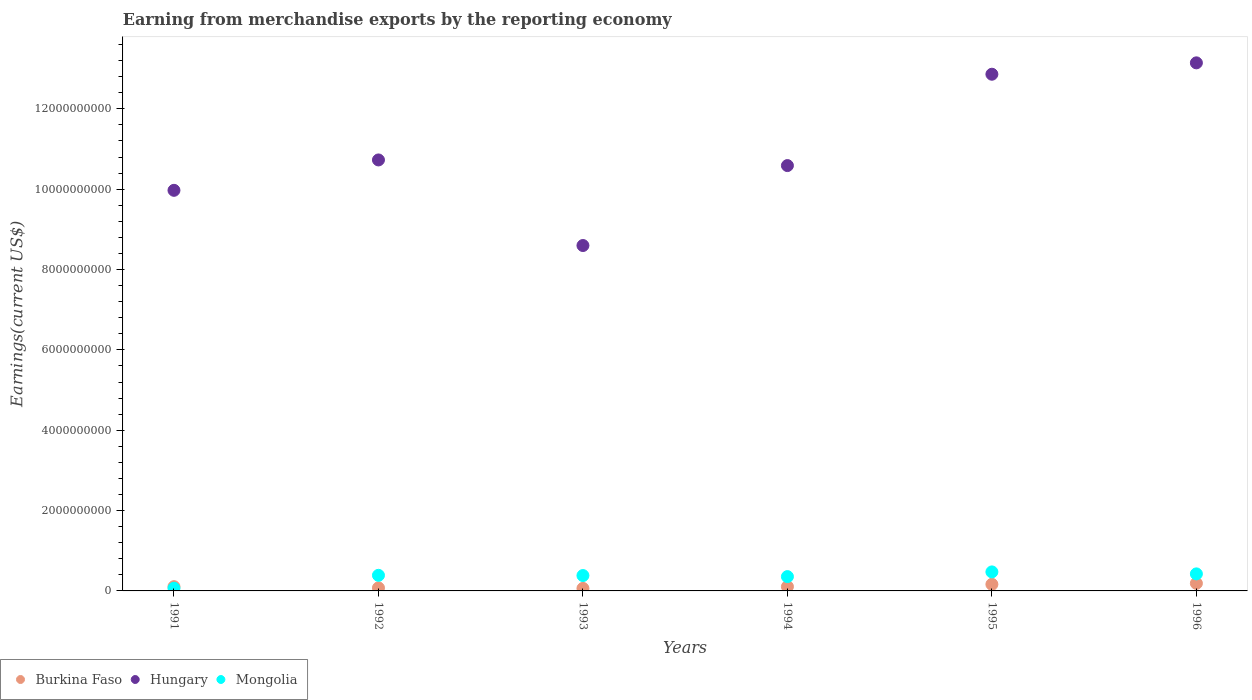Is the number of dotlines equal to the number of legend labels?
Provide a short and direct response. Yes. What is the amount earned from merchandise exports in Hungary in 1994?
Ensure brevity in your answer.  1.06e+1. Across all years, what is the maximum amount earned from merchandise exports in Mongolia?
Give a very brief answer. 4.73e+08. Across all years, what is the minimum amount earned from merchandise exports in Mongolia?
Give a very brief answer. 6.74e+07. In which year was the amount earned from merchandise exports in Burkina Faso maximum?
Your response must be concise. 1996. In which year was the amount earned from merchandise exports in Mongolia minimum?
Provide a succinct answer. 1991. What is the total amount earned from merchandise exports in Hungary in the graph?
Ensure brevity in your answer.  6.59e+1. What is the difference between the amount earned from merchandise exports in Hungary in 1992 and that in 1994?
Make the answer very short. 1.40e+08. What is the difference between the amount earned from merchandise exports in Hungary in 1994 and the amount earned from merchandise exports in Burkina Faso in 1992?
Provide a short and direct response. 1.05e+1. What is the average amount earned from merchandise exports in Mongolia per year?
Offer a terse response. 3.49e+08. In the year 1992, what is the difference between the amount earned from merchandise exports in Burkina Faso and amount earned from merchandise exports in Hungary?
Provide a short and direct response. -1.07e+1. What is the ratio of the amount earned from merchandise exports in Hungary in 1991 to that in 1993?
Ensure brevity in your answer.  1.16. What is the difference between the highest and the second highest amount earned from merchandise exports in Mongolia?
Keep it short and to the point. 4.90e+07. What is the difference between the highest and the lowest amount earned from merchandise exports in Mongolia?
Provide a succinct answer. 4.06e+08. In how many years, is the amount earned from merchandise exports in Hungary greater than the average amount earned from merchandise exports in Hungary taken over all years?
Provide a short and direct response. 2. Is the sum of the amount earned from merchandise exports in Burkina Faso in 1991 and 1996 greater than the maximum amount earned from merchandise exports in Mongolia across all years?
Offer a terse response. No. Is the amount earned from merchandise exports in Hungary strictly greater than the amount earned from merchandise exports in Burkina Faso over the years?
Offer a very short reply. Yes. What is the difference between two consecutive major ticks on the Y-axis?
Provide a succinct answer. 2.00e+09. Does the graph contain any zero values?
Provide a short and direct response. No. Does the graph contain grids?
Keep it short and to the point. No. How are the legend labels stacked?
Provide a succinct answer. Horizontal. What is the title of the graph?
Provide a short and direct response. Earning from merchandise exports by the reporting economy. What is the label or title of the X-axis?
Your answer should be very brief. Years. What is the label or title of the Y-axis?
Your answer should be very brief. Earnings(current US$). What is the Earnings(current US$) in Burkina Faso in 1991?
Your answer should be very brief. 1.06e+08. What is the Earnings(current US$) in Hungary in 1991?
Make the answer very short. 9.97e+09. What is the Earnings(current US$) of Mongolia in 1991?
Ensure brevity in your answer.  6.74e+07. What is the Earnings(current US$) in Burkina Faso in 1992?
Provide a succinct answer. 7.57e+07. What is the Earnings(current US$) in Hungary in 1992?
Offer a terse response. 1.07e+1. What is the Earnings(current US$) in Mongolia in 1992?
Provide a succinct answer. 3.88e+08. What is the Earnings(current US$) in Burkina Faso in 1993?
Provide a short and direct response. 6.25e+07. What is the Earnings(current US$) in Hungary in 1993?
Ensure brevity in your answer.  8.60e+09. What is the Earnings(current US$) in Mongolia in 1993?
Give a very brief answer. 3.83e+08. What is the Earnings(current US$) in Burkina Faso in 1994?
Keep it short and to the point. 1.07e+08. What is the Earnings(current US$) of Hungary in 1994?
Offer a terse response. 1.06e+1. What is the Earnings(current US$) of Mongolia in 1994?
Offer a terse response. 3.56e+08. What is the Earnings(current US$) in Burkina Faso in 1995?
Ensure brevity in your answer.  1.64e+08. What is the Earnings(current US$) of Hungary in 1995?
Make the answer very short. 1.29e+1. What is the Earnings(current US$) of Mongolia in 1995?
Your answer should be very brief. 4.73e+08. What is the Earnings(current US$) of Burkina Faso in 1996?
Provide a short and direct response. 1.89e+08. What is the Earnings(current US$) of Hungary in 1996?
Provide a succinct answer. 1.31e+1. What is the Earnings(current US$) of Mongolia in 1996?
Offer a terse response. 4.24e+08. Across all years, what is the maximum Earnings(current US$) in Burkina Faso?
Your answer should be very brief. 1.89e+08. Across all years, what is the maximum Earnings(current US$) in Hungary?
Keep it short and to the point. 1.31e+1. Across all years, what is the maximum Earnings(current US$) of Mongolia?
Your answer should be very brief. 4.73e+08. Across all years, what is the minimum Earnings(current US$) in Burkina Faso?
Your answer should be very brief. 6.25e+07. Across all years, what is the minimum Earnings(current US$) of Hungary?
Make the answer very short. 8.60e+09. Across all years, what is the minimum Earnings(current US$) in Mongolia?
Your answer should be compact. 6.74e+07. What is the total Earnings(current US$) of Burkina Faso in the graph?
Ensure brevity in your answer.  7.04e+08. What is the total Earnings(current US$) in Hungary in the graph?
Keep it short and to the point. 6.59e+1. What is the total Earnings(current US$) of Mongolia in the graph?
Offer a terse response. 2.09e+09. What is the difference between the Earnings(current US$) in Burkina Faso in 1991 and that in 1992?
Provide a short and direct response. 3.03e+07. What is the difference between the Earnings(current US$) in Hungary in 1991 and that in 1992?
Give a very brief answer. -7.56e+08. What is the difference between the Earnings(current US$) of Mongolia in 1991 and that in 1992?
Give a very brief answer. -3.21e+08. What is the difference between the Earnings(current US$) in Burkina Faso in 1991 and that in 1993?
Provide a short and direct response. 4.34e+07. What is the difference between the Earnings(current US$) of Hungary in 1991 and that in 1993?
Your answer should be very brief. 1.37e+09. What is the difference between the Earnings(current US$) in Mongolia in 1991 and that in 1993?
Offer a very short reply. -3.15e+08. What is the difference between the Earnings(current US$) in Burkina Faso in 1991 and that in 1994?
Give a very brief answer. -7.06e+05. What is the difference between the Earnings(current US$) of Hungary in 1991 and that in 1994?
Provide a short and direct response. -6.16e+08. What is the difference between the Earnings(current US$) in Mongolia in 1991 and that in 1994?
Your answer should be compact. -2.89e+08. What is the difference between the Earnings(current US$) of Burkina Faso in 1991 and that in 1995?
Keep it short and to the point. -5.84e+07. What is the difference between the Earnings(current US$) in Hungary in 1991 and that in 1995?
Ensure brevity in your answer.  -2.89e+09. What is the difference between the Earnings(current US$) of Mongolia in 1991 and that in 1995?
Make the answer very short. -4.06e+08. What is the difference between the Earnings(current US$) of Burkina Faso in 1991 and that in 1996?
Your answer should be compact. -8.27e+07. What is the difference between the Earnings(current US$) of Hungary in 1991 and that in 1996?
Your response must be concise. -3.17e+09. What is the difference between the Earnings(current US$) in Mongolia in 1991 and that in 1996?
Offer a very short reply. -3.57e+08. What is the difference between the Earnings(current US$) in Burkina Faso in 1992 and that in 1993?
Your response must be concise. 1.32e+07. What is the difference between the Earnings(current US$) in Hungary in 1992 and that in 1993?
Offer a very short reply. 2.13e+09. What is the difference between the Earnings(current US$) in Mongolia in 1992 and that in 1993?
Offer a terse response. 5.74e+06. What is the difference between the Earnings(current US$) in Burkina Faso in 1992 and that in 1994?
Ensure brevity in your answer.  -3.10e+07. What is the difference between the Earnings(current US$) of Hungary in 1992 and that in 1994?
Give a very brief answer. 1.40e+08. What is the difference between the Earnings(current US$) of Mongolia in 1992 and that in 1994?
Your response must be concise. 3.23e+07. What is the difference between the Earnings(current US$) of Burkina Faso in 1992 and that in 1995?
Give a very brief answer. -8.86e+07. What is the difference between the Earnings(current US$) of Hungary in 1992 and that in 1995?
Ensure brevity in your answer.  -2.13e+09. What is the difference between the Earnings(current US$) in Mongolia in 1992 and that in 1995?
Give a very brief answer. -8.49e+07. What is the difference between the Earnings(current US$) in Burkina Faso in 1992 and that in 1996?
Keep it short and to the point. -1.13e+08. What is the difference between the Earnings(current US$) in Hungary in 1992 and that in 1996?
Your answer should be compact. -2.42e+09. What is the difference between the Earnings(current US$) in Mongolia in 1992 and that in 1996?
Make the answer very short. -3.59e+07. What is the difference between the Earnings(current US$) in Burkina Faso in 1993 and that in 1994?
Provide a short and direct response. -4.41e+07. What is the difference between the Earnings(current US$) of Hungary in 1993 and that in 1994?
Provide a succinct answer. -1.99e+09. What is the difference between the Earnings(current US$) of Mongolia in 1993 and that in 1994?
Ensure brevity in your answer.  2.66e+07. What is the difference between the Earnings(current US$) in Burkina Faso in 1993 and that in 1995?
Provide a short and direct response. -1.02e+08. What is the difference between the Earnings(current US$) of Hungary in 1993 and that in 1995?
Offer a terse response. -4.26e+09. What is the difference between the Earnings(current US$) in Mongolia in 1993 and that in 1995?
Offer a terse response. -9.06e+07. What is the difference between the Earnings(current US$) in Burkina Faso in 1993 and that in 1996?
Give a very brief answer. -1.26e+08. What is the difference between the Earnings(current US$) of Hungary in 1993 and that in 1996?
Keep it short and to the point. -4.55e+09. What is the difference between the Earnings(current US$) in Mongolia in 1993 and that in 1996?
Give a very brief answer. -4.16e+07. What is the difference between the Earnings(current US$) of Burkina Faso in 1994 and that in 1995?
Your answer should be compact. -5.76e+07. What is the difference between the Earnings(current US$) in Hungary in 1994 and that in 1995?
Give a very brief answer. -2.27e+09. What is the difference between the Earnings(current US$) in Mongolia in 1994 and that in 1995?
Your answer should be compact. -1.17e+08. What is the difference between the Earnings(current US$) in Burkina Faso in 1994 and that in 1996?
Give a very brief answer. -8.20e+07. What is the difference between the Earnings(current US$) of Hungary in 1994 and that in 1996?
Provide a succinct answer. -2.56e+09. What is the difference between the Earnings(current US$) of Mongolia in 1994 and that in 1996?
Ensure brevity in your answer.  -6.82e+07. What is the difference between the Earnings(current US$) in Burkina Faso in 1995 and that in 1996?
Provide a short and direct response. -2.44e+07. What is the difference between the Earnings(current US$) of Hungary in 1995 and that in 1996?
Give a very brief answer. -2.83e+08. What is the difference between the Earnings(current US$) in Mongolia in 1995 and that in 1996?
Your answer should be compact. 4.90e+07. What is the difference between the Earnings(current US$) in Burkina Faso in 1991 and the Earnings(current US$) in Hungary in 1992?
Keep it short and to the point. -1.06e+1. What is the difference between the Earnings(current US$) of Burkina Faso in 1991 and the Earnings(current US$) of Mongolia in 1992?
Offer a very short reply. -2.82e+08. What is the difference between the Earnings(current US$) in Hungary in 1991 and the Earnings(current US$) in Mongolia in 1992?
Your answer should be compact. 9.58e+09. What is the difference between the Earnings(current US$) in Burkina Faso in 1991 and the Earnings(current US$) in Hungary in 1993?
Offer a terse response. -8.49e+09. What is the difference between the Earnings(current US$) of Burkina Faso in 1991 and the Earnings(current US$) of Mongolia in 1993?
Keep it short and to the point. -2.77e+08. What is the difference between the Earnings(current US$) of Hungary in 1991 and the Earnings(current US$) of Mongolia in 1993?
Your response must be concise. 9.59e+09. What is the difference between the Earnings(current US$) in Burkina Faso in 1991 and the Earnings(current US$) in Hungary in 1994?
Your response must be concise. -1.05e+1. What is the difference between the Earnings(current US$) in Burkina Faso in 1991 and the Earnings(current US$) in Mongolia in 1994?
Keep it short and to the point. -2.50e+08. What is the difference between the Earnings(current US$) in Hungary in 1991 and the Earnings(current US$) in Mongolia in 1994?
Provide a short and direct response. 9.62e+09. What is the difference between the Earnings(current US$) in Burkina Faso in 1991 and the Earnings(current US$) in Hungary in 1995?
Make the answer very short. -1.28e+1. What is the difference between the Earnings(current US$) of Burkina Faso in 1991 and the Earnings(current US$) of Mongolia in 1995?
Keep it short and to the point. -3.67e+08. What is the difference between the Earnings(current US$) in Hungary in 1991 and the Earnings(current US$) in Mongolia in 1995?
Make the answer very short. 9.50e+09. What is the difference between the Earnings(current US$) of Burkina Faso in 1991 and the Earnings(current US$) of Hungary in 1996?
Give a very brief answer. -1.30e+1. What is the difference between the Earnings(current US$) in Burkina Faso in 1991 and the Earnings(current US$) in Mongolia in 1996?
Ensure brevity in your answer.  -3.18e+08. What is the difference between the Earnings(current US$) of Hungary in 1991 and the Earnings(current US$) of Mongolia in 1996?
Ensure brevity in your answer.  9.55e+09. What is the difference between the Earnings(current US$) in Burkina Faso in 1992 and the Earnings(current US$) in Hungary in 1993?
Your response must be concise. -8.52e+09. What is the difference between the Earnings(current US$) in Burkina Faso in 1992 and the Earnings(current US$) in Mongolia in 1993?
Your answer should be compact. -3.07e+08. What is the difference between the Earnings(current US$) in Hungary in 1992 and the Earnings(current US$) in Mongolia in 1993?
Provide a succinct answer. 1.03e+1. What is the difference between the Earnings(current US$) in Burkina Faso in 1992 and the Earnings(current US$) in Hungary in 1994?
Keep it short and to the point. -1.05e+1. What is the difference between the Earnings(current US$) of Burkina Faso in 1992 and the Earnings(current US$) of Mongolia in 1994?
Your answer should be compact. -2.80e+08. What is the difference between the Earnings(current US$) of Hungary in 1992 and the Earnings(current US$) of Mongolia in 1994?
Give a very brief answer. 1.04e+1. What is the difference between the Earnings(current US$) of Burkina Faso in 1992 and the Earnings(current US$) of Hungary in 1995?
Give a very brief answer. -1.28e+1. What is the difference between the Earnings(current US$) of Burkina Faso in 1992 and the Earnings(current US$) of Mongolia in 1995?
Make the answer very short. -3.98e+08. What is the difference between the Earnings(current US$) of Hungary in 1992 and the Earnings(current US$) of Mongolia in 1995?
Offer a terse response. 1.03e+1. What is the difference between the Earnings(current US$) in Burkina Faso in 1992 and the Earnings(current US$) in Hungary in 1996?
Offer a terse response. -1.31e+1. What is the difference between the Earnings(current US$) in Burkina Faso in 1992 and the Earnings(current US$) in Mongolia in 1996?
Your answer should be compact. -3.49e+08. What is the difference between the Earnings(current US$) of Hungary in 1992 and the Earnings(current US$) of Mongolia in 1996?
Provide a succinct answer. 1.03e+1. What is the difference between the Earnings(current US$) in Burkina Faso in 1993 and the Earnings(current US$) in Hungary in 1994?
Provide a succinct answer. -1.05e+1. What is the difference between the Earnings(current US$) in Burkina Faso in 1993 and the Earnings(current US$) in Mongolia in 1994?
Your answer should be compact. -2.94e+08. What is the difference between the Earnings(current US$) of Hungary in 1993 and the Earnings(current US$) of Mongolia in 1994?
Provide a succinct answer. 8.24e+09. What is the difference between the Earnings(current US$) of Burkina Faso in 1993 and the Earnings(current US$) of Hungary in 1995?
Give a very brief answer. -1.28e+1. What is the difference between the Earnings(current US$) of Burkina Faso in 1993 and the Earnings(current US$) of Mongolia in 1995?
Give a very brief answer. -4.11e+08. What is the difference between the Earnings(current US$) of Hungary in 1993 and the Earnings(current US$) of Mongolia in 1995?
Provide a short and direct response. 8.12e+09. What is the difference between the Earnings(current US$) of Burkina Faso in 1993 and the Earnings(current US$) of Hungary in 1996?
Keep it short and to the point. -1.31e+1. What is the difference between the Earnings(current US$) in Burkina Faso in 1993 and the Earnings(current US$) in Mongolia in 1996?
Ensure brevity in your answer.  -3.62e+08. What is the difference between the Earnings(current US$) of Hungary in 1993 and the Earnings(current US$) of Mongolia in 1996?
Provide a short and direct response. 8.17e+09. What is the difference between the Earnings(current US$) in Burkina Faso in 1994 and the Earnings(current US$) in Hungary in 1995?
Offer a terse response. -1.28e+1. What is the difference between the Earnings(current US$) of Burkina Faso in 1994 and the Earnings(current US$) of Mongolia in 1995?
Provide a succinct answer. -3.67e+08. What is the difference between the Earnings(current US$) of Hungary in 1994 and the Earnings(current US$) of Mongolia in 1995?
Offer a very short reply. 1.01e+1. What is the difference between the Earnings(current US$) of Burkina Faso in 1994 and the Earnings(current US$) of Hungary in 1996?
Provide a succinct answer. -1.30e+1. What is the difference between the Earnings(current US$) in Burkina Faso in 1994 and the Earnings(current US$) in Mongolia in 1996?
Provide a succinct answer. -3.18e+08. What is the difference between the Earnings(current US$) in Hungary in 1994 and the Earnings(current US$) in Mongolia in 1996?
Offer a terse response. 1.02e+1. What is the difference between the Earnings(current US$) of Burkina Faso in 1995 and the Earnings(current US$) of Hungary in 1996?
Your answer should be compact. -1.30e+1. What is the difference between the Earnings(current US$) of Burkina Faso in 1995 and the Earnings(current US$) of Mongolia in 1996?
Give a very brief answer. -2.60e+08. What is the difference between the Earnings(current US$) of Hungary in 1995 and the Earnings(current US$) of Mongolia in 1996?
Provide a short and direct response. 1.24e+1. What is the average Earnings(current US$) of Burkina Faso per year?
Keep it short and to the point. 1.17e+08. What is the average Earnings(current US$) in Hungary per year?
Your answer should be compact. 1.10e+1. What is the average Earnings(current US$) in Mongolia per year?
Your response must be concise. 3.49e+08. In the year 1991, what is the difference between the Earnings(current US$) of Burkina Faso and Earnings(current US$) of Hungary?
Make the answer very short. -9.87e+09. In the year 1991, what is the difference between the Earnings(current US$) in Burkina Faso and Earnings(current US$) in Mongolia?
Your answer should be compact. 3.86e+07. In the year 1991, what is the difference between the Earnings(current US$) in Hungary and Earnings(current US$) in Mongolia?
Ensure brevity in your answer.  9.90e+09. In the year 1992, what is the difference between the Earnings(current US$) of Burkina Faso and Earnings(current US$) of Hungary?
Your answer should be compact. -1.07e+1. In the year 1992, what is the difference between the Earnings(current US$) of Burkina Faso and Earnings(current US$) of Mongolia?
Give a very brief answer. -3.13e+08. In the year 1992, what is the difference between the Earnings(current US$) in Hungary and Earnings(current US$) in Mongolia?
Provide a short and direct response. 1.03e+1. In the year 1993, what is the difference between the Earnings(current US$) of Burkina Faso and Earnings(current US$) of Hungary?
Offer a terse response. -8.54e+09. In the year 1993, what is the difference between the Earnings(current US$) in Burkina Faso and Earnings(current US$) in Mongolia?
Provide a short and direct response. -3.20e+08. In the year 1993, what is the difference between the Earnings(current US$) in Hungary and Earnings(current US$) in Mongolia?
Provide a short and direct response. 8.22e+09. In the year 1994, what is the difference between the Earnings(current US$) of Burkina Faso and Earnings(current US$) of Hungary?
Your answer should be compact. -1.05e+1. In the year 1994, what is the difference between the Earnings(current US$) in Burkina Faso and Earnings(current US$) in Mongolia?
Provide a succinct answer. -2.49e+08. In the year 1994, what is the difference between the Earnings(current US$) in Hungary and Earnings(current US$) in Mongolia?
Keep it short and to the point. 1.02e+1. In the year 1995, what is the difference between the Earnings(current US$) in Burkina Faso and Earnings(current US$) in Hungary?
Provide a succinct answer. -1.27e+1. In the year 1995, what is the difference between the Earnings(current US$) of Burkina Faso and Earnings(current US$) of Mongolia?
Offer a very short reply. -3.09e+08. In the year 1995, what is the difference between the Earnings(current US$) of Hungary and Earnings(current US$) of Mongolia?
Ensure brevity in your answer.  1.24e+1. In the year 1996, what is the difference between the Earnings(current US$) in Burkina Faso and Earnings(current US$) in Hungary?
Provide a succinct answer. -1.30e+1. In the year 1996, what is the difference between the Earnings(current US$) in Burkina Faso and Earnings(current US$) in Mongolia?
Provide a succinct answer. -2.36e+08. In the year 1996, what is the difference between the Earnings(current US$) of Hungary and Earnings(current US$) of Mongolia?
Provide a succinct answer. 1.27e+1. What is the ratio of the Earnings(current US$) in Burkina Faso in 1991 to that in 1992?
Provide a succinct answer. 1.4. What is the ratio of the Earnings(current US$) in Hungary in 1991 to that in 1992?
Keep it short and to the point. 0.93. What is the ratio of the Earnings(current US$) of Mongolia in 1991 to that in 1992?
Ensure brevity in your answer.  0.17. What is the ratio of the Earnings(current US$) of Burkina Faso in 1991 to that in 1993?
Give a very brief answer. 1.69. What is the ratio of the Earnings(current US$) in Hungary in 1991 to that in 1993?
Offer a terse response. 1.16. What is the ratio of the Earnings(current US$) of Mongolia in 1991 to that in 1993?
Give a very brief answer. 0.18. What is the ratio of the Earnings(current US$) in Hungary in 1991 to that in 1994?
Offer a terse response. 0.94. What is the ratio of the Earnings(current US$) of Mongolia in 1991 to that in 1994?
Ensure brevity in your answer.  0.19. What is the ratio of the Earnings(current US$) in Burkina Faso in 1991 to that in 1995?
Your answer should be very brief. 0.64. What is the ratio of the Earnings(current US$) in Hungary in 1991 to that in 1995?
Your response must be concise. 0.78. What is the ratio of the Earnings(current US$) of Mongolia in 1991 to that in 1995?
Offer a very short reply. 0.14. What is the ratio of the Earnings(current US$) of Burkina Faso in 1991 to that in 1996?
Offer a very short reply. 0.56. What is the ratio of the Earnings(current US$) in Hungary in 1991 to that in 1996?
Offer a very short reply. 0.76. What is the ratio of the Earnings(current US$) in Mongolia in 1991 to that in 1996?
Your answer should be very brief. 0.16. What is the ratio of the Earnings(current US$) in Burkina Faso in 1992 to that in 1993?
Offer a terse response. 1.21. What is the ratio of the Earnings(current US$) of Hungary in 1992 to that in 1993?
Provide a short and direct response. 1.25. What is the ratio of the Earnings(current US$) of Burkina Faso in 1992 to that in 1994?
Keep it short and to the point. 0.71. What is the ratio of the Earnings(current US$) in Hungary in 1992 to that in 1994?
Your answer should be very brief. 1.01. What is the ratio of the Earnings(current US$) in Mongolia in 1992 to that in 1994?
Your answer should be compact. 1.09. What is the ratio of the Earnings(current US$) of Burkina Faso in 1992 to that in 1995?
Provide a succinct answer. 0.46. What is the ratio of the Earnings(current US$) in Hungary in 1992 to that in 1995?
Give a very brief answer. 0.83. What is the ratio of the Earnings(current US$) in Mongolia in 1992 to that in 1995?
Your answer should be compact. 0.82. What is the ratio of the Earnings(current US$) in Burkina Faso in 1992 to that in 1996?
Your answer should be compact. 0.4. What is the ratio of the Earnings(current US$) in Hungary in 1992 to that in 1996?
Your answer should be very brief. 0.82. What is the ratio of the Earnings(current US$) in Mongolia in 1992 to that in 1996?
Your answer should be very brief. 0.92. What is the ratio of the Earnings(current US$) of Burkina Faso in 1993 to that in 1994?
Provide a short and direct response. 0.59. What is the ratio of the Earnings(current US$) in Hungary in 1993 to that in 1994?
Provide a short and direct response. 0.81. What is the ratio of the Earnings(current US$) in Mongolia in 1993 to that in 1994?
Keep it short and to the point. 1.07. What is the ratio of the Earnings(current US$) in Burkina Faso in 1993 to that in 1995?
Keep it short and to the point. 0.38. What is the ratio of the Earnings(current US$) in Hungary in 1993 to that in 1995?
Ensure brevity in your answer.  0.67. What is the ratio of the Earnings(current US$) of Mongolia in 1993 to that in 1995?
Ensure brevity in your answer.  0.81. What is the ratio of the Earnings(current US$) in Burkina Faso in 1993 to that in 1996?
Your response must be concise. 0.33. What is the ratio of the Earnings(current US$) in Hungary in 1993 to that in 1996?
Offer a terse response. 0.65. What is the ratio of the Earnings(current US$) in Mongolia in 1993 to that in 1996?
Your answer should be very brief. 0.9. What is the ratio of the Earnings(current US$) in Burkina Faso in 1994 to that in 1995?
Offer a terse response. 0.65. What is the ratio of the Earnings(current US$) in Hungary in 1994 to that in 1995?
Keep it short and to the point. 0.82. What is the ratio of the Earnings(current US$) in Mongolia in 1994 to that in 1995?
Your answer should be compact. 0.75. What is the ratio of the Earnings(current US$) of Burkina Faso in 1994 to that in 1996?
Provide a succinct answer. 0.57. What is the ratio of the Earnings(current US$) of Hungary in 1994 to that in 1996?
Ensure brevity in your answer.  0.81. What is the ratio of the Earnings(current US$) in Mongolia in 1994 to that in 1996?
Your response must be concise. 0.84. What is the ratio of the Earnings(current US$) of Burkina Faso in 1995 to that in 1996?
Provide a short and direct response. 0.87. What is the ratio of the Earnings(current US$) in Hungary in 1995 to that in 1996?
Provide a short and direct response. 0.98. What is the ratio of the Earnings(current US$) in Mongolia in 1995 to that in 1996?
Offer a very short reply. 1.12. What is the difference between the highest and the second highest Earnings(current US$) in Burkina Faso?
Provide a succinct answer. 2.44e+07. What is the difference between the highest and the second highest Earnings(current US$) in Hungary?
Offer a terse response. 2.83e+08. What is the difference between the highest and the second highest Earnings(current US$) in Mongolia?
Offer a very short reply. 4.90e+07. What is the difference between the highest and the lowest Earnings(current US$) of Burkina Faso?
Your response must be concise. 1.26e+08. What is the difference between the highest and the lowest Earnings(current US$) in Hungary?
Your answer should be very brief. 4.55e+09. What is the difference between the highest and the lowest Earnings(current US$) of Mongolia?
Your answer should be very brief. 4.06e+08. 